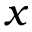<formula> <loc_0><loc_0><loc_500><loc_500>x</formula> 